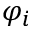<formula> <loc_0><loc_0><loc_500><loc_500>\varphi _ { i }</formula> 